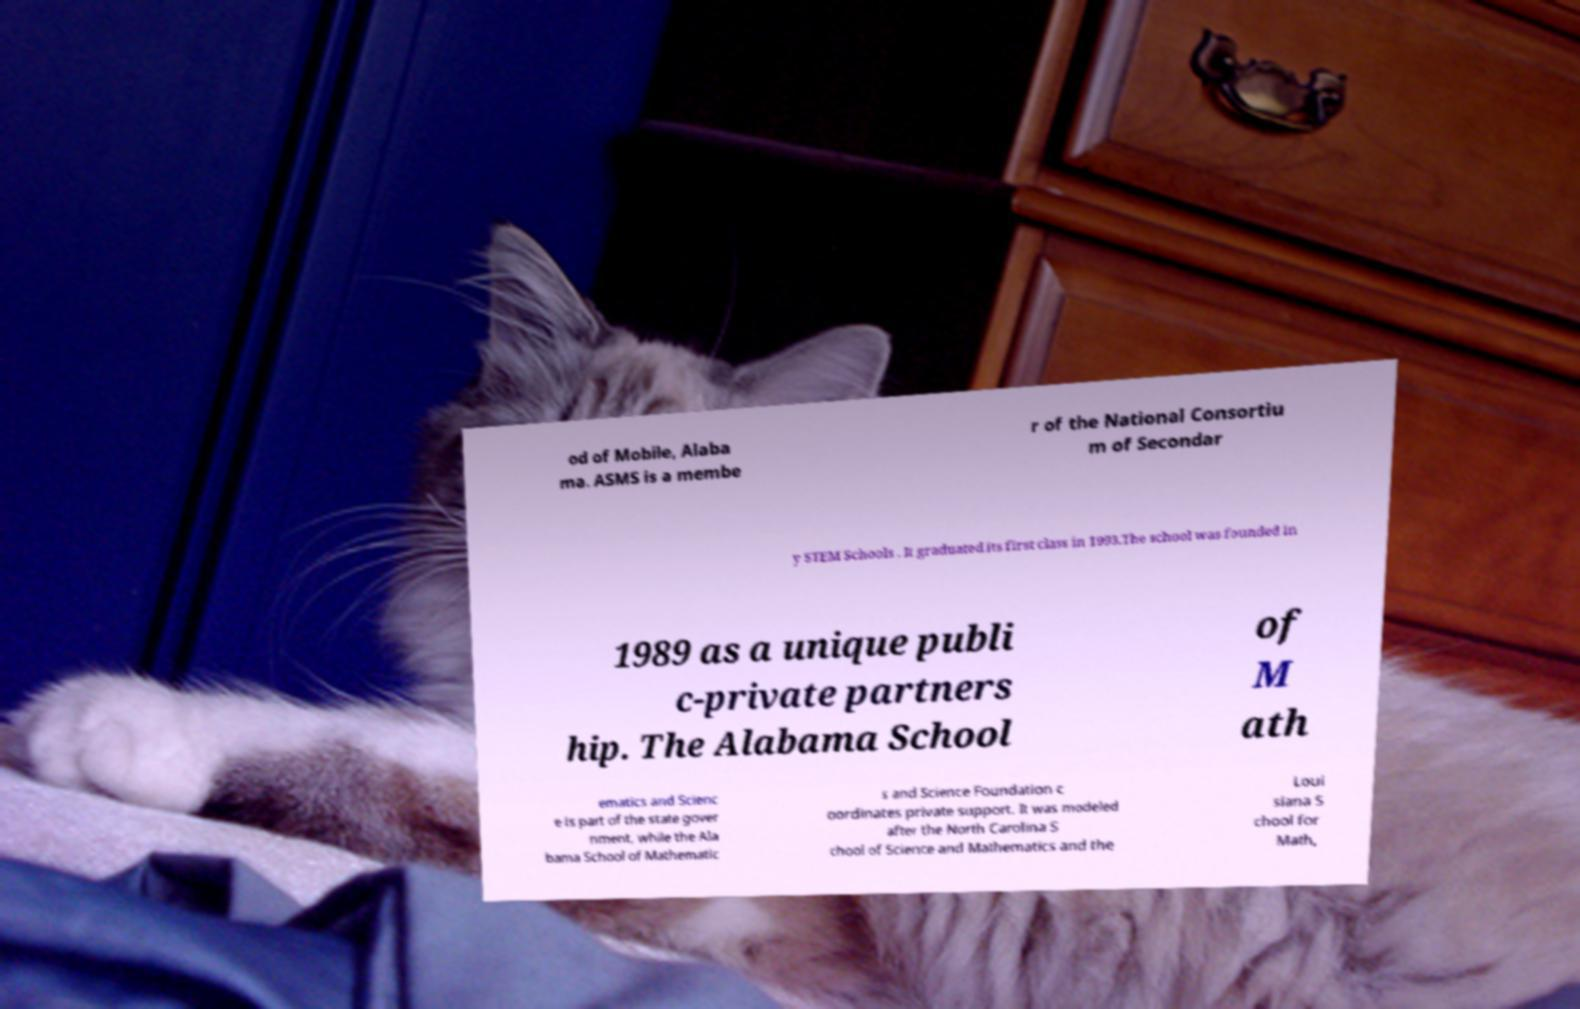Can you accurately transcribe the text from the provided image for me? od of Mobile, Alaba ma. ASMS is a membe r of the National Consortiu m of Secondar y STEM Schools . It graduated its first class in 1993.The school was founded in 1989 as a unique publi c-private partners hip. The Alabama School of M ath ematics and Scienc e is part of the state gover nment, while the Ala bama School of Mathematic s and Science Foundation c oordinates private support. It was modeled after the North Carolina S chool of Science and Mathematics and the Loui siana S chool for Math, 